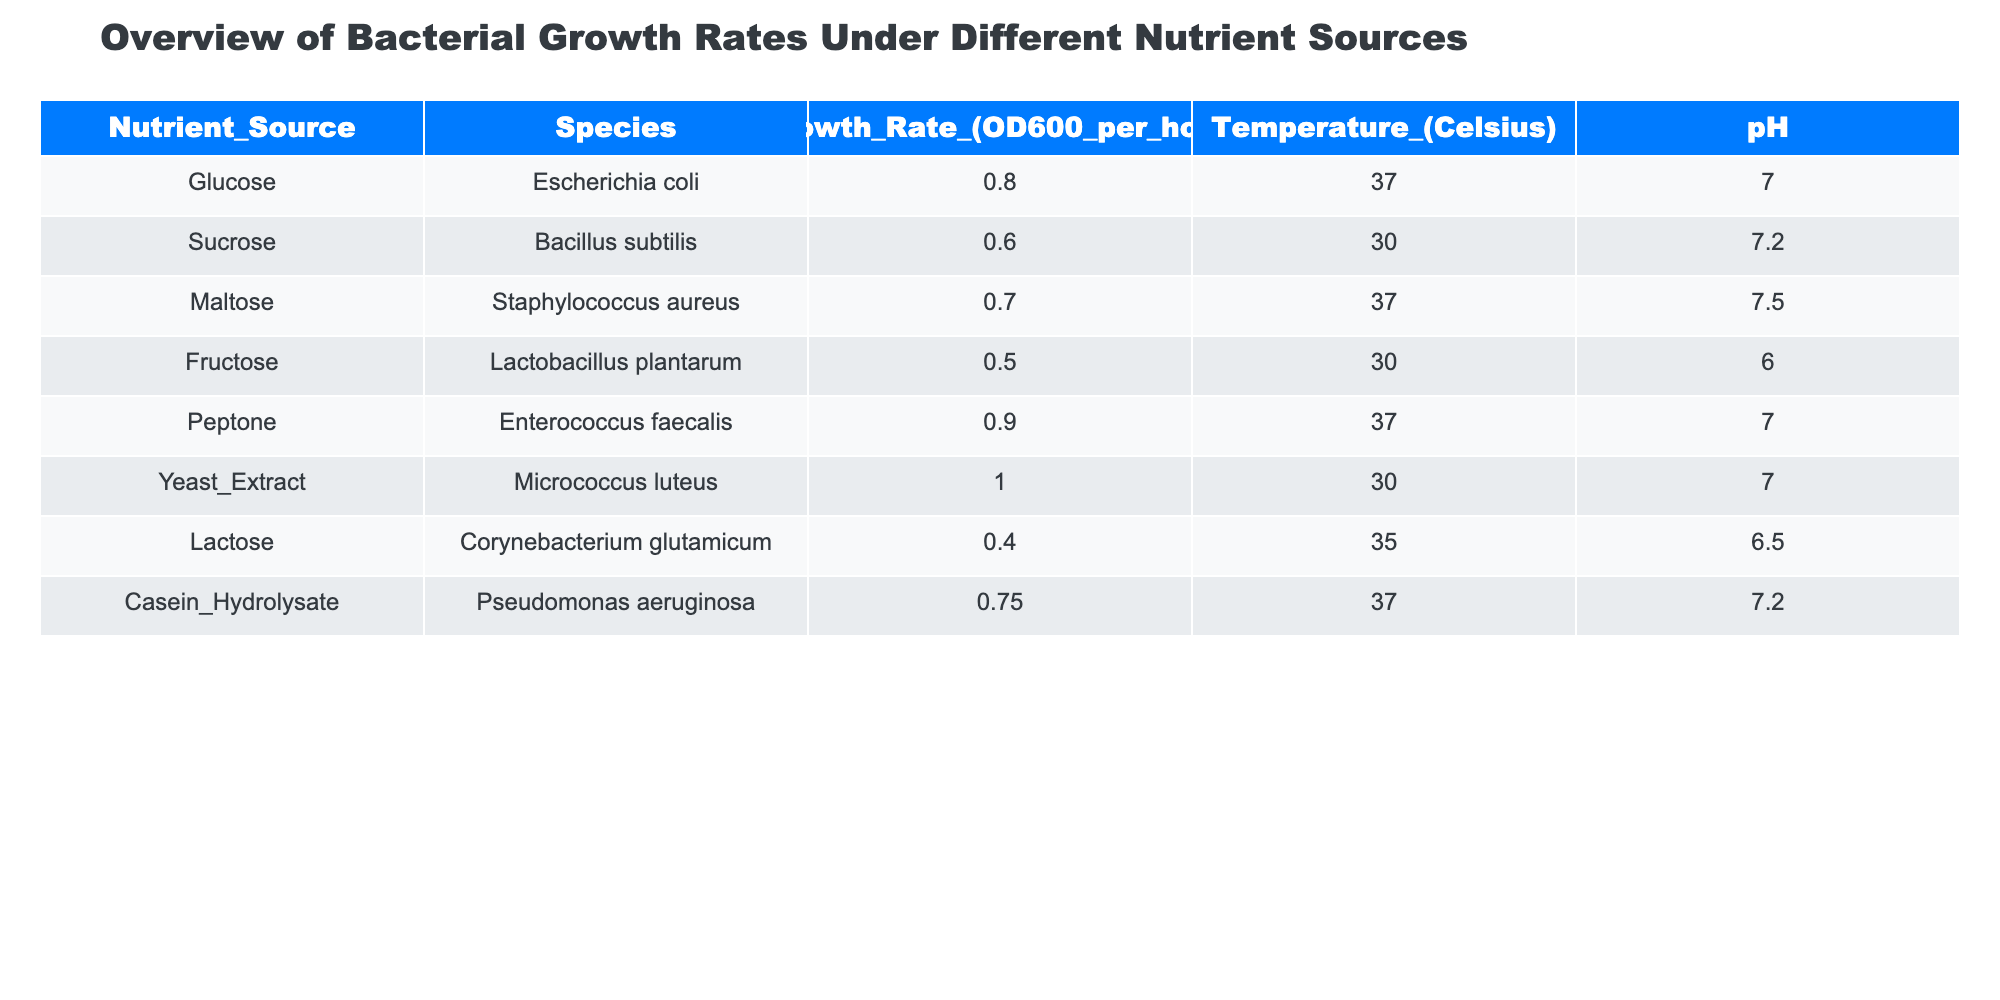What is the growth rate of Enterococcus faecalis? Enterococcus faecalis has a growth rate listed under the Nutrient Source of Peptone. By referring to the table, the growth rate is 0.9 OD600 per hour.
Answer: 0.9 Which bacterial species has the highest growth rate and what is that rate? Looking through the table, Micrococcus luteus has the highest growth rate of 1.0 OD600 per hour, as indicated in the Yeast Extract nutrient source row.
Answer: 1.0 What is the average growth rate across all species in the table? To calculate the average, sum the growth rates: (0.8 + 0.6 + 0.7 + 0.5 + 0.9 + 1.0 + 0.4 + 0.75) = 5.95. There are 8 species, so divide by 8: 5.95/8 = 0.74375. The average growth rate is approximately 0.74 OD600 per hour.
Answer: 0.74 Is the pH for Lactobacillus plantarum above 6? The pH for Lactobacillus plantarum, which uses Fructose as a nutrient source, is listed as 6.0. Thus, it is not above 6.
Answer: No Which nutrient source leads to the lowest growth rate, and what is the corresponding growth rate? The table displays Lactose as the nutrient source for Corynebacterium glutamicum, which has the lowest growth rate of 0.4 OD600 per hour. This can be directly read from the Nutrient_Source and Growth_Rate columns.
Answer: 0.4 Do any species have a growth rate of 0.6 or higher when using Sucrose as a nutrient source? Sucrose is used by Bacillus subtilis with a growth rate of 0.6 OD600 per hour. Therefore, this fulfills the condition of having a growth rate of 0.6 or higher.
Answer: Yes How does the growth rate of Staphylococcus aureus compare to that of Corynebacterium glutamicum? Staphylococcus aureus has a growth rate of 0.7 OD600 per hour, whereas Corynebacterium glutamicum has a rate of 0.4 OD600 per hour. The difference is calculated as 0.7 - 0.4 = 0.3, which means Staphylococcus aureus grows 0.3 faster than Corynebacterium glutamicum.
Answer: 0.3 Which nutrient source results in a growth rate of 0.5 or lower? The table shows that Fructose, used by Lactobacillus plantarum, results in a growth rate of 0.5, and Lactose, used by Corynebacterium glutamicum, has a growth rate of 0.4. Therefore, both nutrient sources meet this criterion.
Answer: Fructose and Lactose What is the temperature at which Micrococcus luteus grows? The temperature for Micrococcus luteus, which utilizes Yeast Extract, is specified in the Temperature column as 30 degrees Celsius. This value can be directly referenced from the table.
Answer: 30 